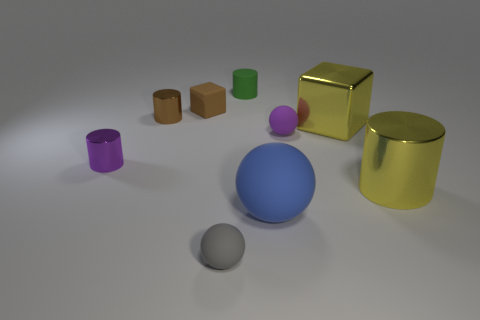There is a big metal object that is the same color as the large metallic block; what is its shape?
Provide a succinct answer. Cylinder. What is the material of the tiny purple object that is the same shape as the tiny green object?
Your answer should be compact. Metal. There is a metal object that is right of the big yellow shiny thing that is behind the tiny rubber thing that is right of the blue matte ball; what shape is it?
Give a very brief answer. Cylinder. What is the material of the object that is behind the tiny purple rubber object and to the right of the tiny matte cylinder?
Keep it short and to the point. Metal. What shape is the yellow thing in front of the tiny ball behind the blue rubber sphere?
Your response must be concise. Cylinder. Are there any other things that have the same color as the large matte ball?
Give a very brief answer. No. Do the brown cylinder and the purple thing that is on the right side of the gray rubber sphere have the same size?
Ensure brevity in your answer.  Yes. What number of small things are either purple metallic cylinders or things?
Offer a very short reply. 6. Is the number of metal spheres greater than the number of green things?
Keep it short and to the point. No. There is a cylinder on the right side of the cube in front of the small brown rubber cube; what number of large yellow shiny objects are on the right side of it?
Offer a terse response. 0. 